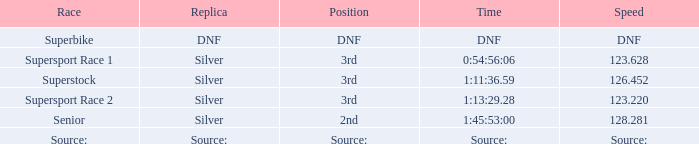Which race has a position of 3rd and a speed of 126.452? Superstock. 